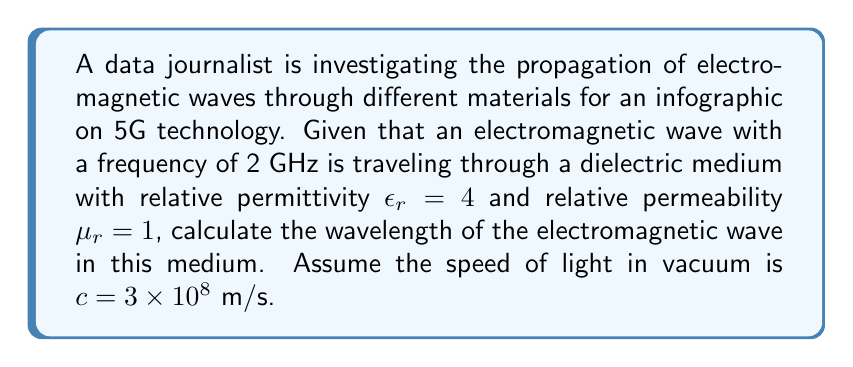Teach me how to tackle this problem. To solve this problem, we'll use Maxwell's equations and their implications for electromagnetic wave propagation in different media. Here's a step-by-step approach:

1) First, recall the relationship between wavelength $\lambda$, frequency $f$, and wave speed $v$:

   $$\lambda = \frac{v}{f}$$

2) In a medium, the speed of electromagnetic waves is given by:

   $$v = \frac{c}{\sqrt{\epsilon_r \mu_r}}$$

   Where $c$ is the speed of light in vacuum, $\epsilon_r$ is the relative permittivity, and $\mu_r$ is the relative permeability of the medium.

3) Substitute the given values:
   $f = 2 \times 10^9$ Hz
   $\epsilon_r = 4$
   $\mu_r = 1$
   $c = 3 \times 10^8$ m/s

4) Calculate the wave speed in the medium:

   $$v = \frac{3 \times 10^8}{\sqrt{4 \times 1}} = 1.5 \times 10^8 \text{ m/s}$$

5) Now, calculate the wavelength:

   $$\lambda = \frac{v}{f} = \frac{1.5 \times 10^8}{2 \times 10^9} = 0.075 \text{ m}$$

6) Convert to centimeters:

   $$\lambda = 0.075 \text{ m} \times 100 \text{ cm/m} = 7.5 \text{ cm}$$
Answer: 7.5 cm 